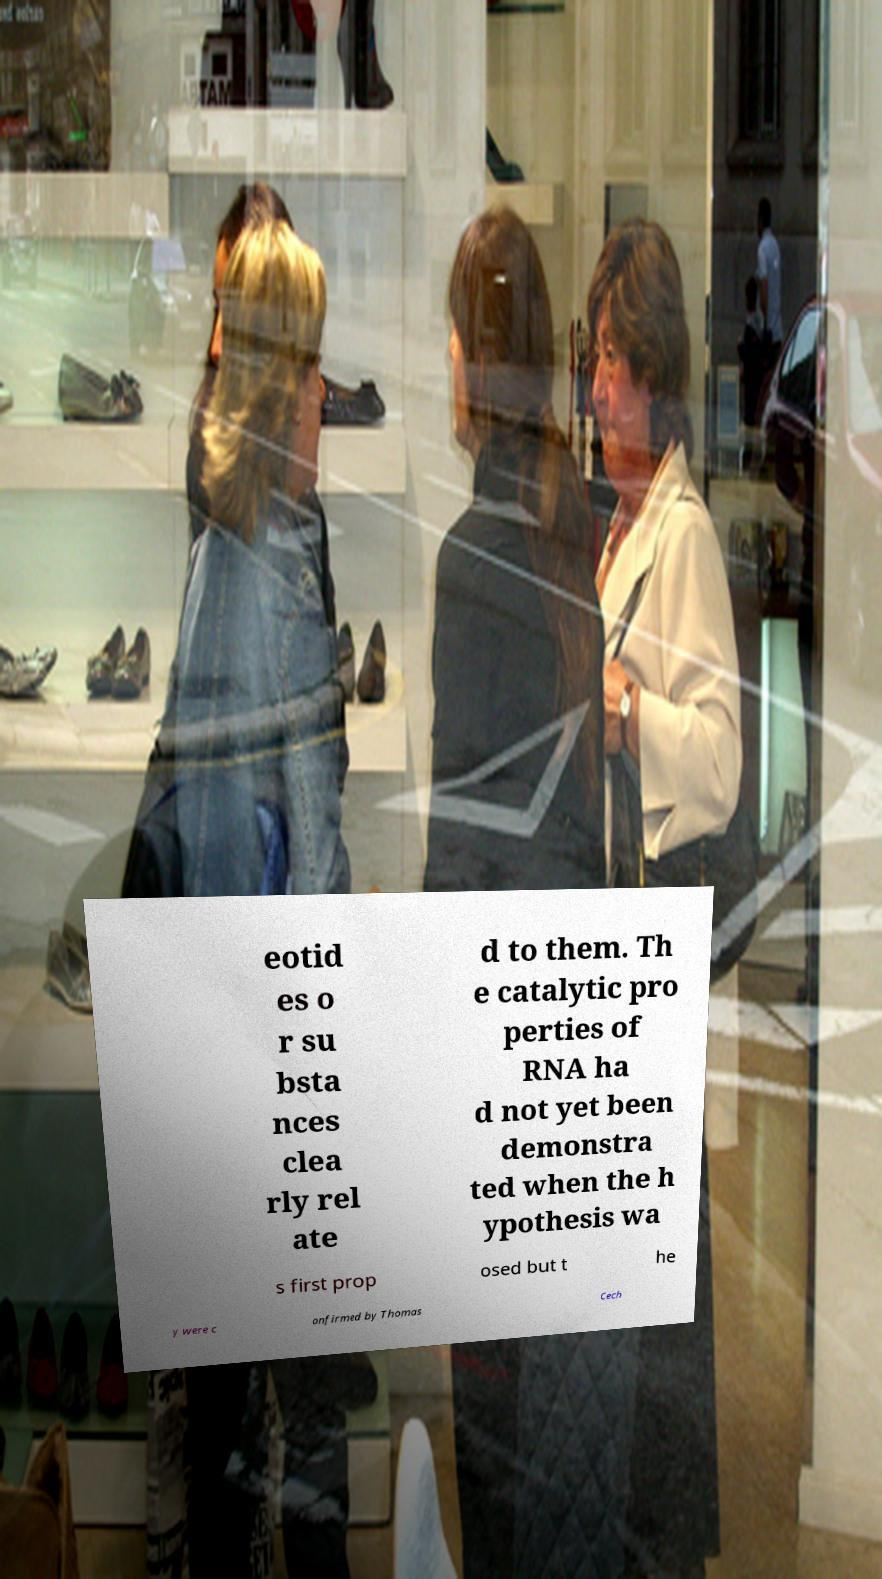Could you assist in decoding the text presented in this image and type it out clearly? eotid es o r su bsta nces clea rly rel ate d to them. Th e catalytic pro perties of RNA ha d not yet been demonstra ted when the h ypothesis wa s first prop osed but t he y were c onfirmed by Thomas Cech 